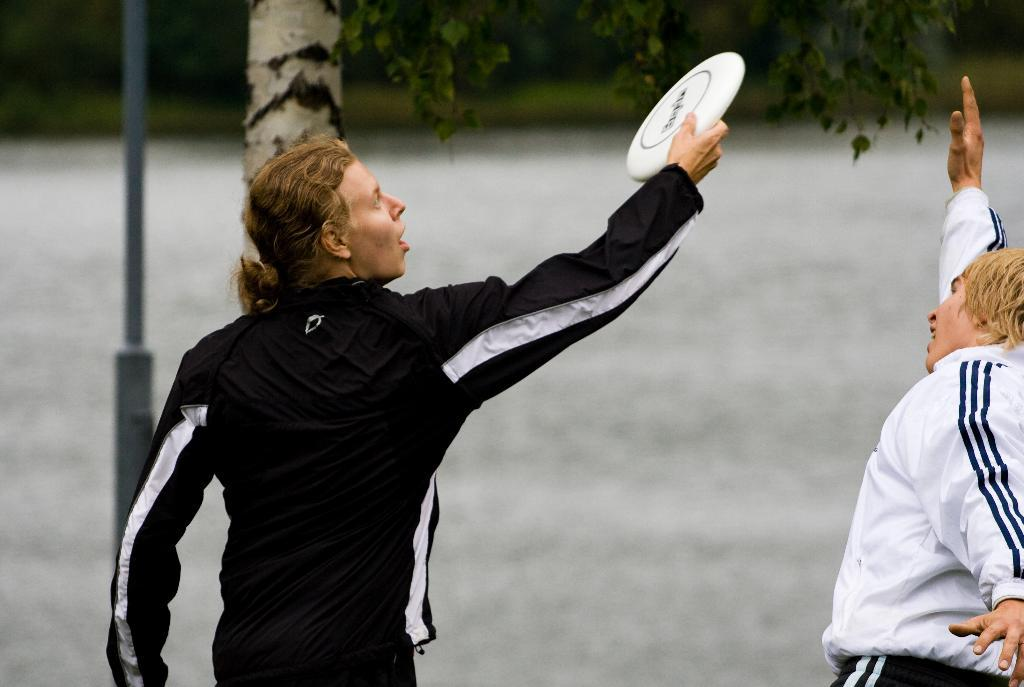How many people are in the image? There are two persons in the image. Where is the first person located? The first person is on the left side. What is the first person holding in their hand? The person on the left side is holding an object in their hand. What can be seen in the background of the image? There is a tree and a pole in the background of the image. What type of fish can be seen swimming near the tree in the image? There are no fish present in the image; it features two persons and background elements of a tree and a pole. 